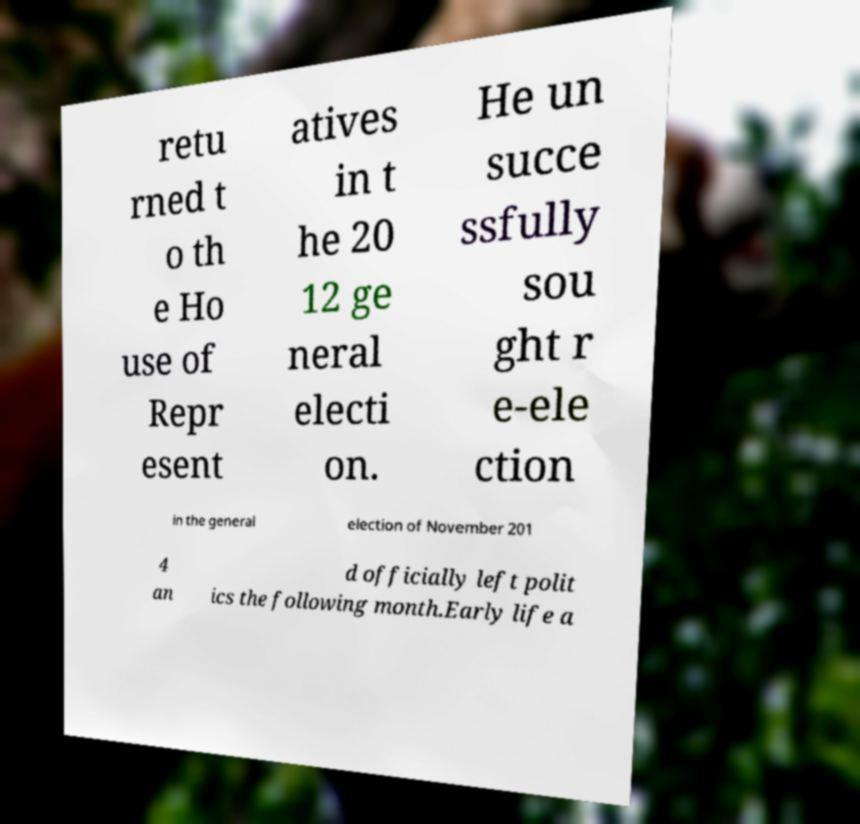Can you accurately transcribe the text from the provided image for me? retu rned t o th e Ho use of Repr esent atives in t he 20 12 ge neral electi on. He un succe ssfully sou ght r e-ele ction in the general election of November 201 4 an d officially left polit ics the following month.Early life a 